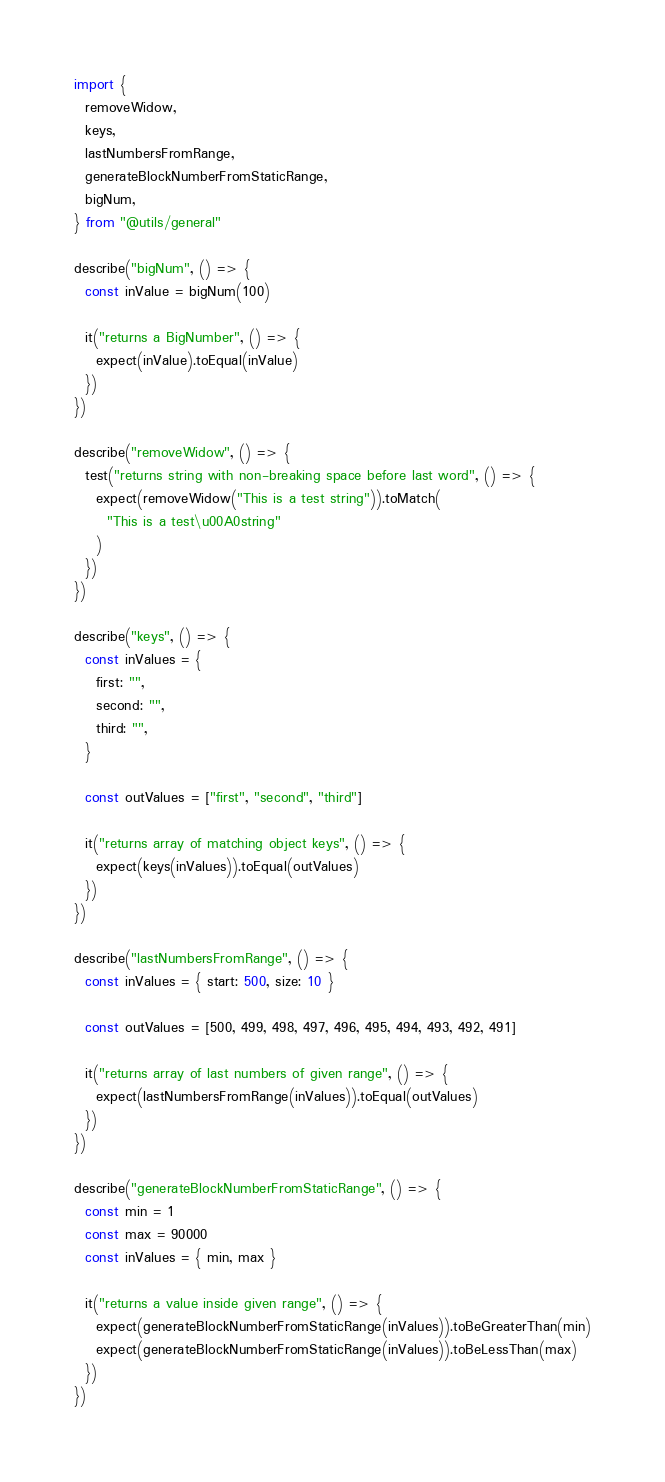Convert code to text. <code><loc_0><loc_0><loc_500><loc_500><_TypeScript_>import {
  removeWidow,
  keys,
  lastNumbersFromRange,
  generateBlockNumberFromStaticRange,
  bigNum,
} from "@utils/general"

describe("bigNum", () => {
  const inValue = bigNum(100)

  it("returns a BigNumber", () => {
    expect(inValue).toEqual(inValue)
  })
})

describe("removeWidow", () => {
  test("returns string with non-breaking space before last word", () => {
    expect(removeWidow("This is a test string")).toMatch(
      "This is a test\u00A0string"
    )
  })
})

describe("keys", () => {
  const inValues = {
    first: "",
    second: "",
    third: "",
  }

  const outValues = ["first", "second", "third"]

  it("returns array of matching object keys", () => {
    expect(keys(inValues)).toEqual(outValues)
  })
})

describe("lastNumbersFromRange", () => {
  const inValues = { start: 500, size: 10 }

  const outValues = [500, 499, 498, 497, 496, 495, 494, 493, 492, 491]

  it("returns array of last numbers of given range", () => {
    expect(lastNumbersFromRange(inValues)).toEqual(outValues)
  })
})

describe("generateBlockNumberFromStaticRange", () => {
  const min = 1
  const max = 90000
  const inValues = { min, max }

  it("returns a value inside given range", () => {
    expect(generateBlockNumberFromStaticRange(inValues)).toBeGreaterThan(min)
    expect(generateBlockNumberFromStaticRange(inValues)).toBeLessThan(max)
  })
})
</code> 